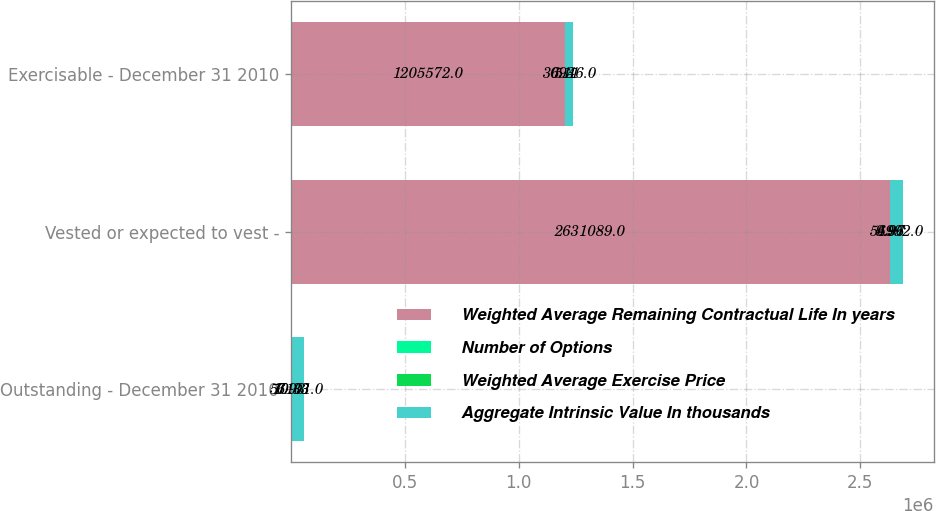<chart> <loc_0><loc_0><loc_500><loc_500><stacked_bar_chart><ecel><fcel>Outstanding - December 31 2010<fcel>Vested or expected to vest -<fcel>Exercisable - December 31 2010<nl><fcel>Weighted Average Remaining Contractual Life In years<fcel>10.33<fcel>2.63109e+06<fcel>1.20557e+06<nl><fcel>Number of Options<fcel>10.33<fcel>9.96<fcel>6.11<nl><fcel>Weighted Average Exercise Price<fcel>6.93<fcel>4.97<fcel>5.3<nl><fcel>Aggregate Intrinsic Value In thousands<fcel>57101<fcel>56992<fcel>30946<nl></chart> 